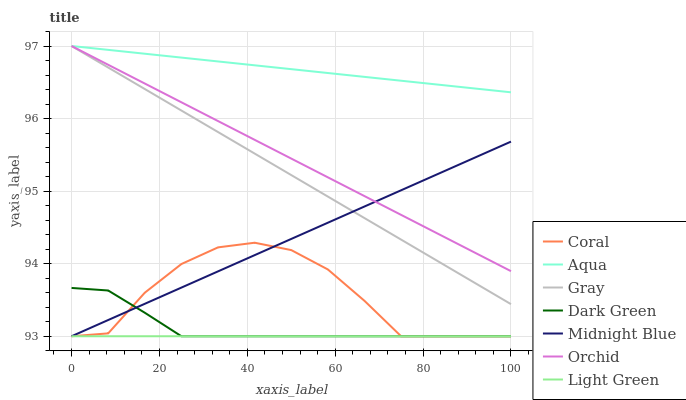Does Light Green have the minimum area under the curve?
Answer yes or no. Yes. Does Aqua have the maximum area under the curve?
Answer yes or no. Yes. Does Midnight Blue have the minimum area under the curve?
Answer yes or no. No. Does Midnight Blue have the maximum area under the curve?
Answer yes or no. No. Is Light Green the smoothest?
Answer yes or no. Yes. Is Coral the roughest?
Answer yes or no. Yes. Is Midnight Blue the smoothest?
Answer yes or no. No. Is Midnight Blue the roughest?
Answer yes or no. No. Does Midnight Blue have the lowest value?
Answer yes or no. Yes. Does Aqua have the lowest value?
Answer yes or no. No. Does Orchid have the highest value?
Answer yes or no. Yes. Does Midnight Blue have the highest value?
Answer yes or no. No. Is Light Green less than Orchid?
Answer yes or no. Yes. Is Orchid greater than Light Green?
Answer yes or no. Yes. Does Coral intersect Midnight Blue?
Answer yes or no. Yes. Is Coral less than Midnight Blue?
Answer yes or no. No. Is Coral greater than Midnight Blue?
Answer yes or no. No. Does Light Green intersect Orchid?
Answer yes or no. No. 